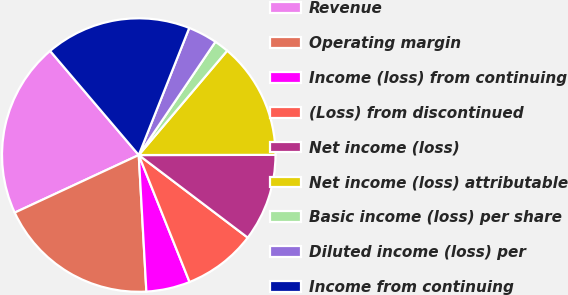Convert chart. <chart><loc_0><loc_0><loc_500><loc_500><pie_chart><fcel>Revenue<fcel>Operating margin<fcel>Income (loss) from continuing<fcel>(Loss) from discontinued<fcel>Net income (loss)<fcel>Net income (loss) attributable<fcel>Basic income (loss) per share<fcel>Diluted income (loss) per<fcel>Income from continuing<nl><fcel>20.69%<fcel>18.97%<fcel>5.17%<fcel>8.62%<fcel>10.34%<fcel>13.79%<fcel>1.72%<fcel>3.45%<fcel>17.24%<nl></chart> 